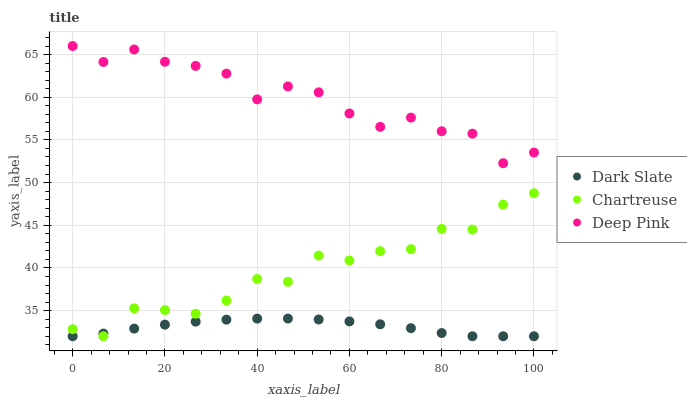Does Dark Slate have the minimum area under the curve?
Answer yes or no. Yes. Does Deep Pink have the maximum area under the curve?
Answer yes or no. Yes. Does Chartreuse have the minimum area under the curve?
Answer yes or no. No. Does Chartreuse have the maximum area under the curve?
Answer yes or no. No. Is Dark Slate the smoothest?
Answer yes or no. Yes. Is Deep Pink the roughest?
Answer yes or no. Yes. Is Chartreuse the smoothest?
Answer yes or no. No. Is Chartreuse the roughest?
Answer yes or no. No. Does Dark Slate have the lowest value?
Answer yes or no. Yes. Does Deep Pink have the lowest value?
Answer yes or no. No. Does Deep Pink have the highest value?
Answer yes or no. Yes. Does Chartreuse have the highest value?
Answer yes or no. No. Is Chartreuse less than Deep Pink?
Answer yes or no. Yes. Is Deep Pink greater than Dark Slate?
Answer yes or no. Yes. Does Chartreuse intersect Dark Slate?
Answer yes or no. Yes. Is Chartreuse less than Dark Slate?
Answer yes or no. No. Is Chartreuse greater than Dark Slate?
Answer yes or no. No. Does Chartreuse intersect Deep Pink?
Answer yes or no. No. 